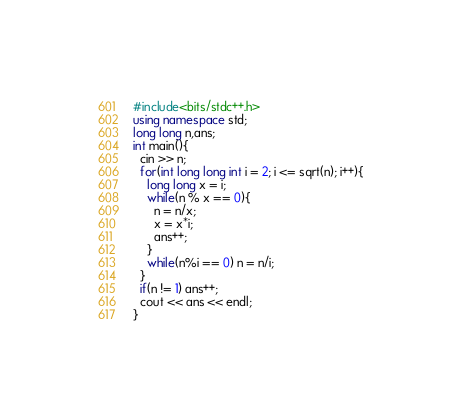Convert code to text. <code><loc_0><loc_0><loc_500><loc_500><_C++_>#include<bits/stdc++.h>
using namespace std;
long long n,ans;
int main(){
  cin >> n;
  for(int long long int i = 2; i <= sqrt(n); i++){
    long long x = i;
    while(n % x == 0){
      n = n/x;
      x = x*i;
      ans++;
    }
    while(n%i == 0) n = n/i;
  }
  if(n != 1) ans++;
  cout << ans << endl;
}</code> 